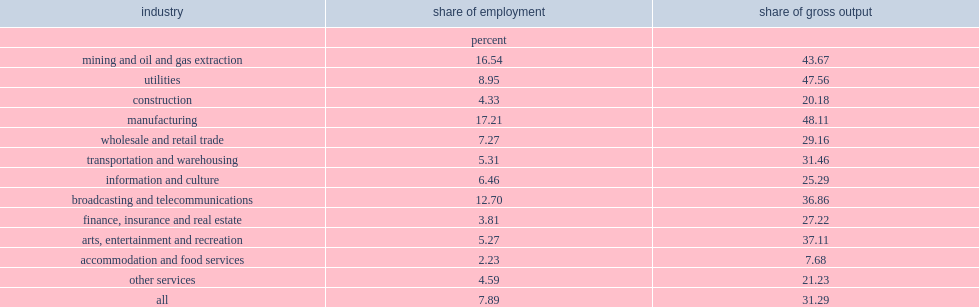What was the percent of total employment of frontier firms for the period of 1991 to 2015? 7.89. What was the percent of gross output in canadian industries of frontier firms for the period of 1991 to 2015? 31.29. What was the percent of total employment of frontier firms for the period of 1991 to 2015? 7.89. What was the percent of gross output in canadian industries of frontier firms for the period of 1991 to 2015? 31.29. 